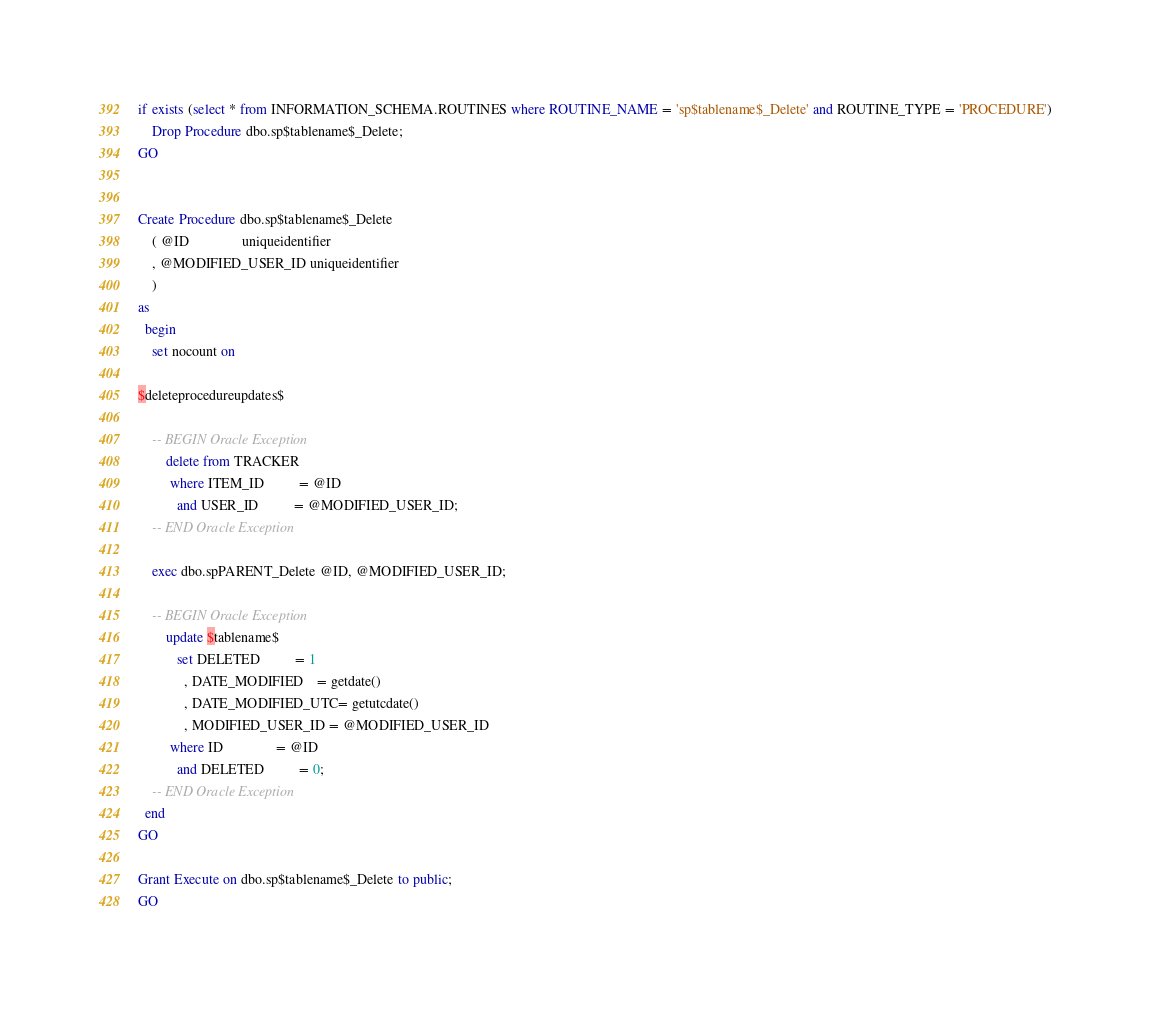<code> <loc_0><loc_0><loc_500><loc_500><_SQL_>if exists (select * from INFORMATION_SCHEMA.ROUTINES where ROUTINE_NAME = 'sp$tablename$_Delete' and ROUTINE_TYPE = 'PROCEDURE')
	Drop Procedure dbo.sp$tablename$_Delete;
GO


Create Procedure dbo.sp$tablename$_Delete
	( @ID               uniqueidentifier
	, @MODIFIED_USER_ID uniqueidentifier
	)
as
  begin
	set nocount on
	
$deleteprocedureupdates$
	
	-- BEGIN Oracle Exception
		delete from TRACKER
		 where ITEM_ID          = @ID
		   and USER_ID          = @MODIFIED_USER_ID;
	-- END Oracle Exception
	
	exec dbo.spPARENT_Delete @ID, @MODIFIED_USER_ID;
	
	-- BEGIN Oracle Exception
		update $tablename$
		   set DELETED          = 1
		     , DATE_MODIFIED    = getdate()
		     , DATE_MODIFIED_UTC= getutcdate()
		     , MODIFIED_USER_ID = @MODIFIED_USER_ID
		 where ID               = @ID
		   and DELETED          = 0;
	-- END Oracle Exception
  end
GO

Grant Execute on dbo.sp$tablename$_Delete to public;
GO

</code> 